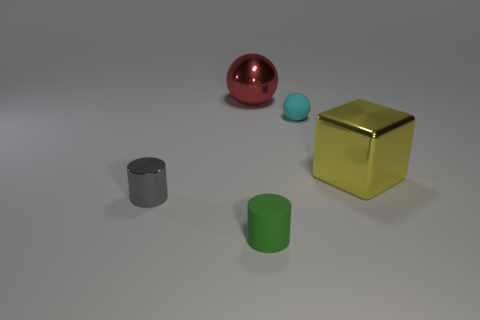Add 5 balls. How many objects exist? 10 Subtract all red balls. How many balls are left? 1 Subtract 1 spheres. How many spheres are left? 1 Subtract all balls. How many objects are left? 3 Subtract 0 brown cylinders. How many objects are left? 5 Subtract all purple balls. Subtract all green cylinders. How many balls are left? 2 Subtract all cyan matte things. Subtract all small matte spheres. How many objects are left? 3 Add 1 yellow things. How many yellow things are left? 2 Add 4 tiny gray metal things. How many tiny gray metal things exist? 5 